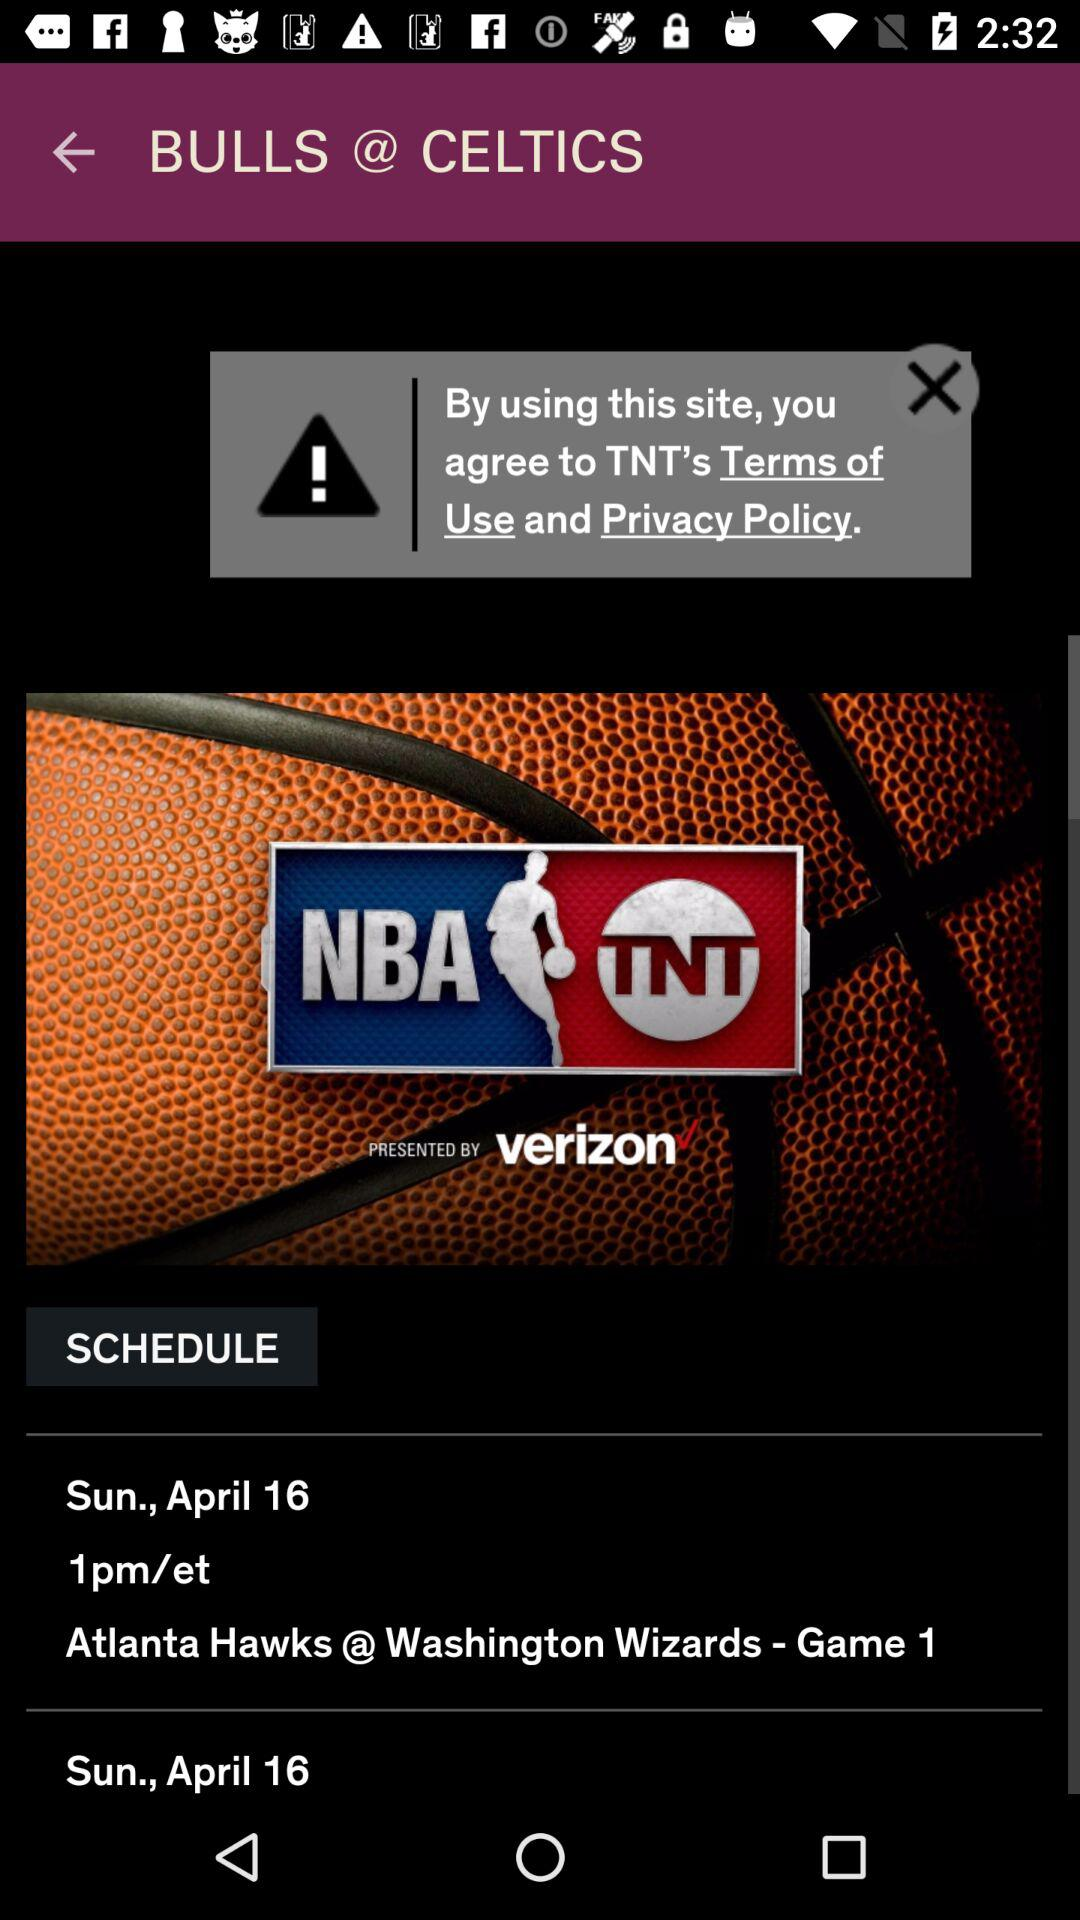What time has been scheduled? The time that has been scheduled is 1 p.m. ET. 